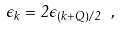<formula> <loc_0><loc_0><loc_500><loc_500>\epsilon _ { k } = 2 \epsilon _ { ( { k } + { Q } ) / 2 } \ ,</formula> 